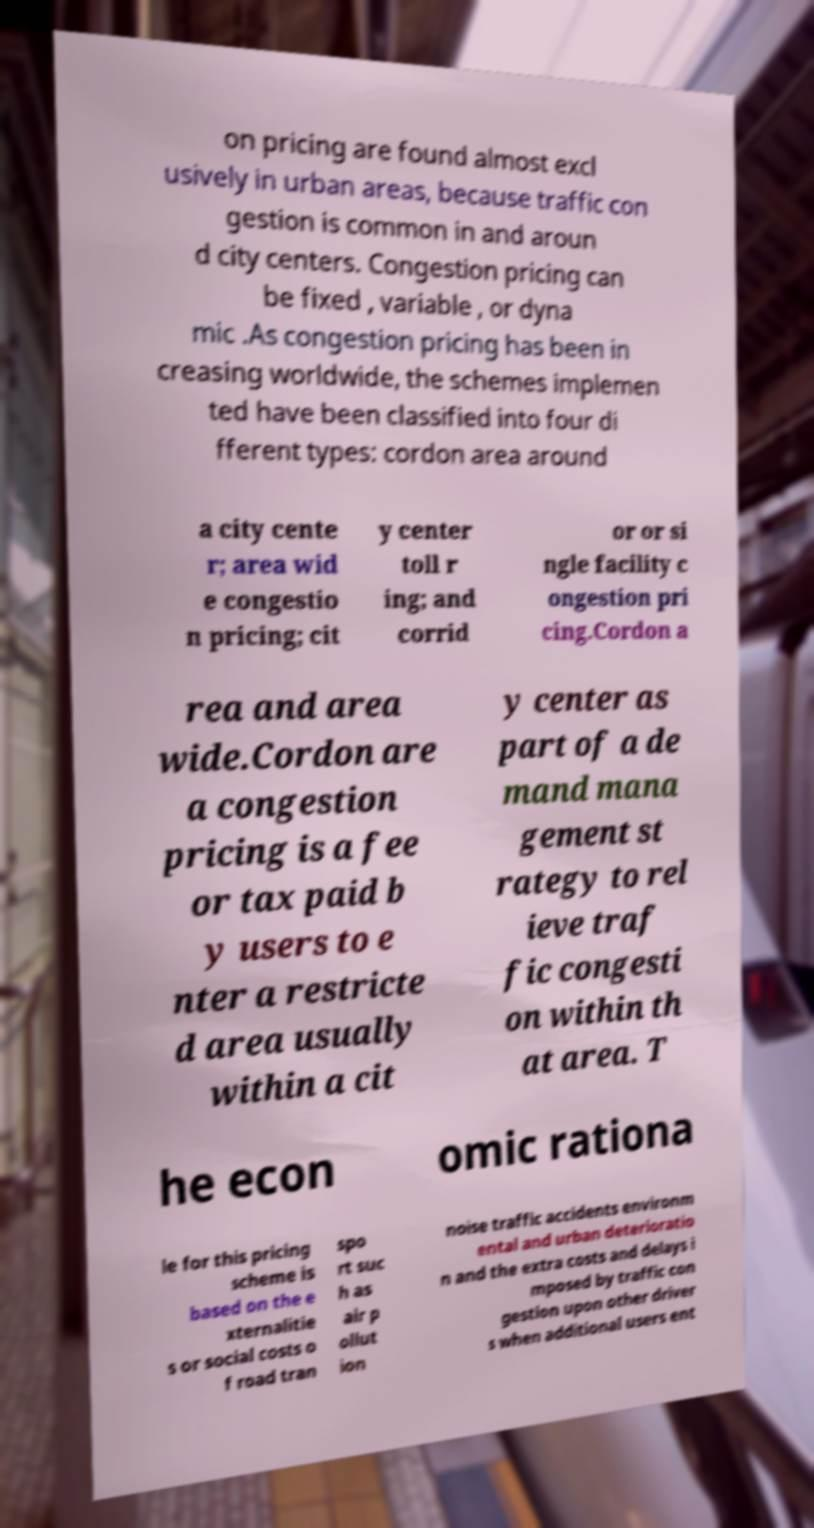Can you accurately transcribe the text from the provided image for me? on pricing are found almost excl usively in urban areas, because traffic con gestion is common in and aroun d city centers. Congestion pricing can be fixed , variable , or dyna mic .As congestion pricing has been in creasing worldwide, the schemes implemen ted have been classified into four di fferent types: cordon area around a city cente r; area wid e congestio n pricing; cit y center toll r ing; and corrid or or si ngle facility c ongestion pri cing.Cordon a rea and area wide.Cordon are a congestion pricing is a fee or tax paid b y users to e nter a restricte d area usually within a cit y center as part of a de mand mana gement st rategy to rel ieve traf fic congesti on within th at area. T he econ omic rationa le for this pricing scheme is based on the e xternalitie s or social costs o f road tran spo rt suc h as air p ollut ion noise traffic accidents environm ental and urban deterioratio n and the extra costs and delays i mposed by traffic con gestion upon other driver s when additional users ent 